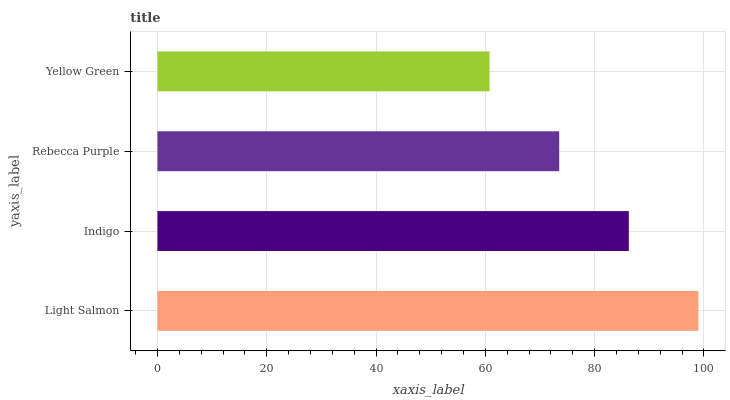Is Yellow Green the minimum?
Answer yes or no. Yes. Is Light Salmon the maximum?
Answer yes or no. Yes. Is Indigo the minimum?
Answer yes or no. No. Is Indigo the maximum?
Answer yes or no. No. Is Light Salmon greater than Indigo?
Answer yes or no. Yes. Is Indigo less than Light Salmon?
Answer yes or no. Yes. Is Indigo greater than Light Salmon?
Answer yes or no. No. Is Light Salmon less than Indigo?
Answer yes or no. No. Is Indigo the high median?
Answer yes or no. Yes. Is Rebecca Purple the low median?
Answer yes or no. Yes. Is Yellow Green the high median?
Answer yes or no. No. Is Yellow Green the low median?
Answer yes or no. No. 